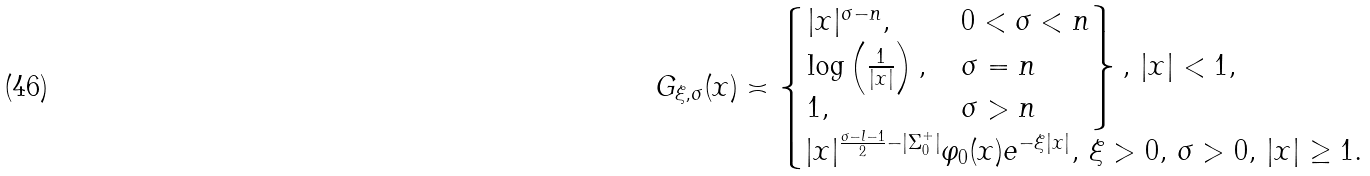<formula> <loc_0><loc_0><loc_500><loc_500>G _ { \xi , \sigma } ( x ) \asymp \begin{cases} \begin{rcases} | x | ^ { \sigma - n } , \, & 0 < \sigma < n \\ \log \left ( \frac { 1 } { | x | } \right ) , \, & \sigma = n \\ 1 , & \sigma > n \end{rcases} , \, | x | < 1 , \\ | x | ^ { \frac { \sigma - l - 1 } { 2 } - | \Sigma ^ { + } _ { 0 } | } \varphi _ { 0 } ( x ) e ^ { - \xi | x | } , \, \xi > 0 , \, \sigma > 0 , \, | x | \geq 1 . \, \end{cases}</formula> 